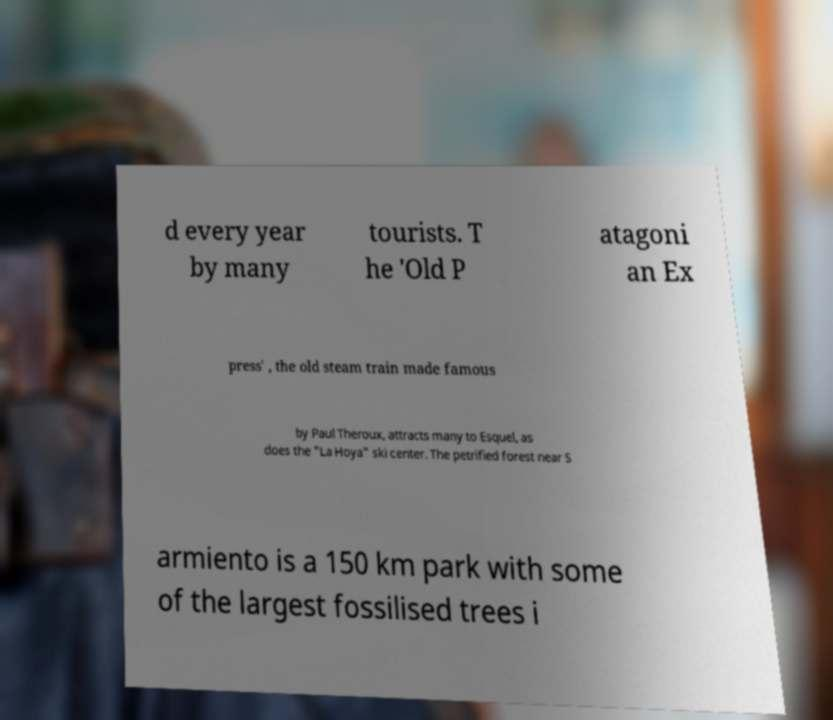Can you read and provide the text displayed in the image?This photo seems to have some interesting text. Can you extract and type it out for me? d every year by many tourists. T he 'Old P atagoni an Ex press' , the old steam train made famous by Paul Theroux, attracts many to Esquel, as does the "La Hoya" ski center. The petrified forest near S armiento is a 150 km park with some of the largest fossilised trees i 